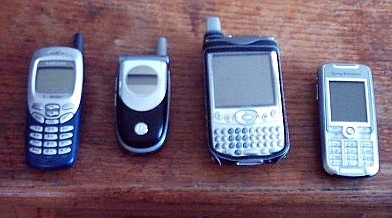Describe the objects in this image and their specific colors. I can see cell phone in brown, darkgray, lightblue, and gray tones, cell phone in brown, navy, gray, and lightblue tones, cell phone in brown, lightblue, and gray tones, and cell phone in brown, black, lightblue, and darkgray tones in this image. 